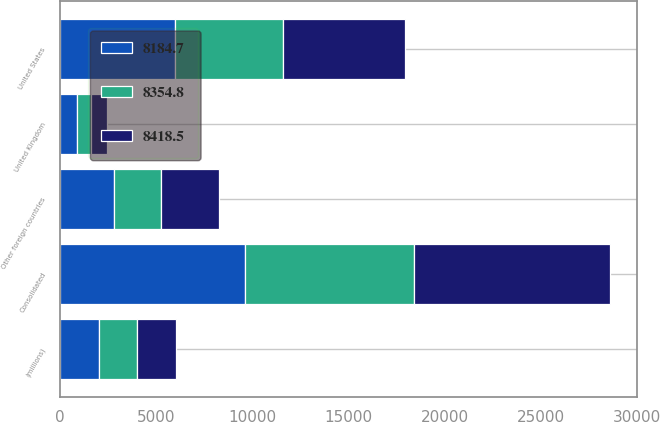Convert chart. <chart><loc_0><loc_0><loc_500><loc_500><stacked_bar_chart><ecel><fcel>(millions)<fcel>United States<fcel>United Kingdom<fcel>Other foreign countries<fcel>Consolidated<nl><fcel>8418.5<fcel>2005<fcel>6351.6<fcel>836.9<fcel>2988.7<fcel>10177.2<nl><fcel>8184.7<fcel>2004<fcel>5968<fcel>859.6<fcel>2786.3<fcel>9613.9<nl><fcel>8354.8<fcel>2003<fcel>5608.3<fcel>740.2<fcel>2463<fcel>8811.5<nl></chart> 